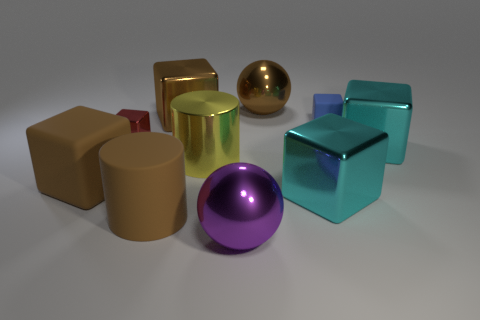What shape is the small object on the left side of the tiny object to the right of the large ball that is in front of the large yellow shiny cylinder?
Ensure brevity in your answer.  Cube. The rubber cylinder that is the same size as the brown metal sphere is what color?
Keep it short and to the point. Brown. How many other small rubber things have the same shape as the small red object?
Offer a terse response. 1. There is a yellow cylinder; is its size the same as the brown metallic object that is in front of the big brown sphere?
Your answer should be very brief. Yes. The rubber thing on the left side of the large brown matte thing right of the small red object is what shape?
Provide a succinct answer. Cube. Is the number of large rubber objects that are right of the big brown matte block less than the number of brown cubes?
Make the answer very short. Yes. There is a matte object that is the same color as the matte cylinder; what is its shape?
Your response must be concise. Cube. What number of cyan shiny blocks have the same size as the red shiny block?
Ensure brevity in your answer.  0. The large brown object that is in front of the big matte block has what shape?
Provide a short and direct response. Cylinder. Is the number of small matte blocks less than the number of matte blocks?
Your response must be concise. Yes. 